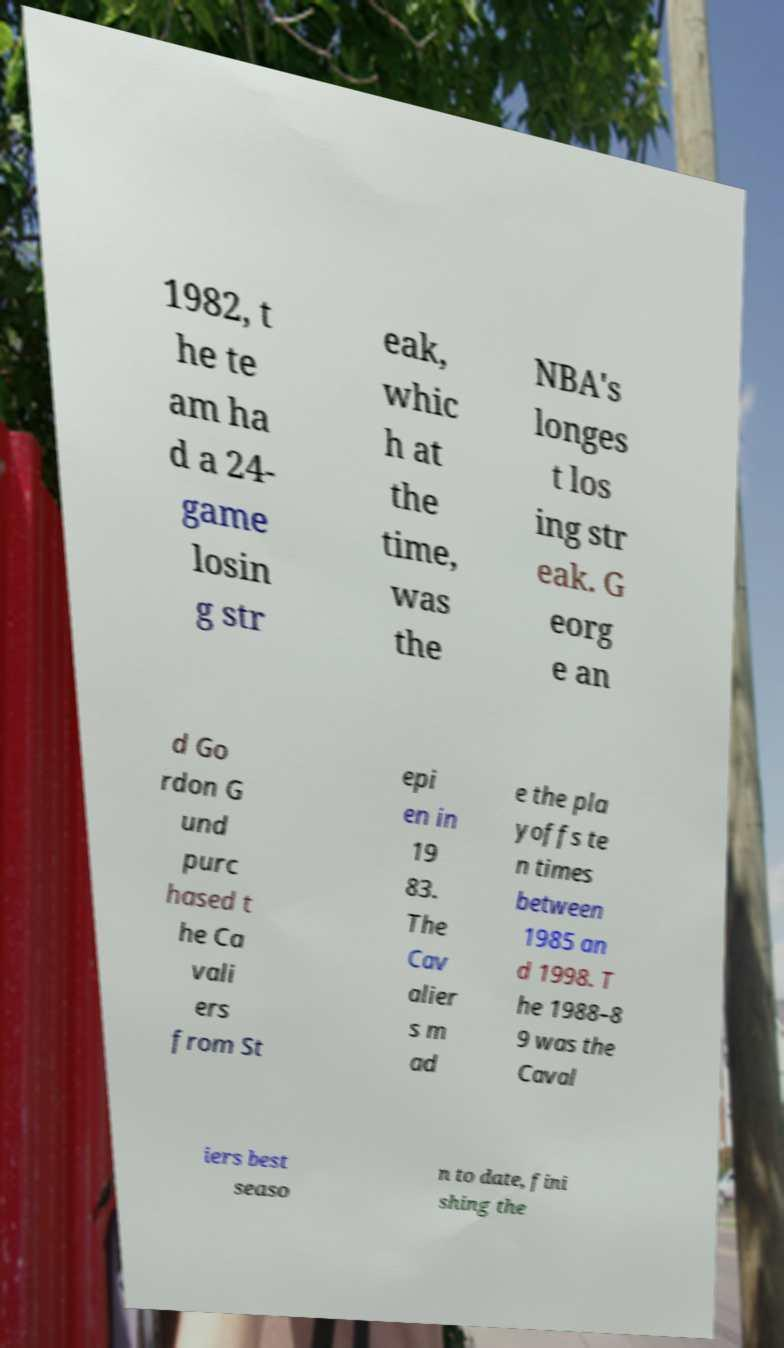Could you assist in decoding the text presented in this image and type it out clearly? 1982, t he te am ha d a 24- game losin g str eak, whic h at the time, was the NBA's longes t los ing str eak. G eorg e an d Go rdon G und purc hased t he Ca vali ers from St epi en in 19 83. The Cav alier s m ad e the pla yoffs te n times between 1985 an d 1998. T he 1988–8 9 was the Caval iers best seaso n to date, fini shing the 